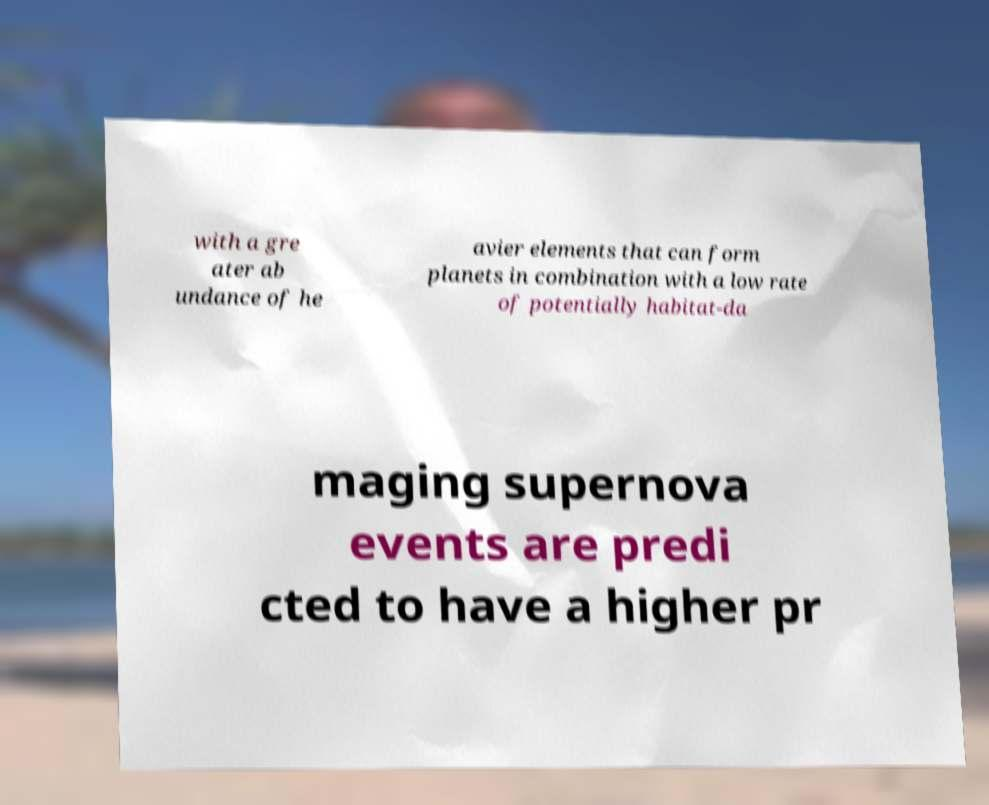Please identify and transcribe the text found in this image. with a gre ater ab undance of he avier elements that can form planets in combination with a low rate of potentially habitat-da maging supernova events are predi cted to have a higher pr 